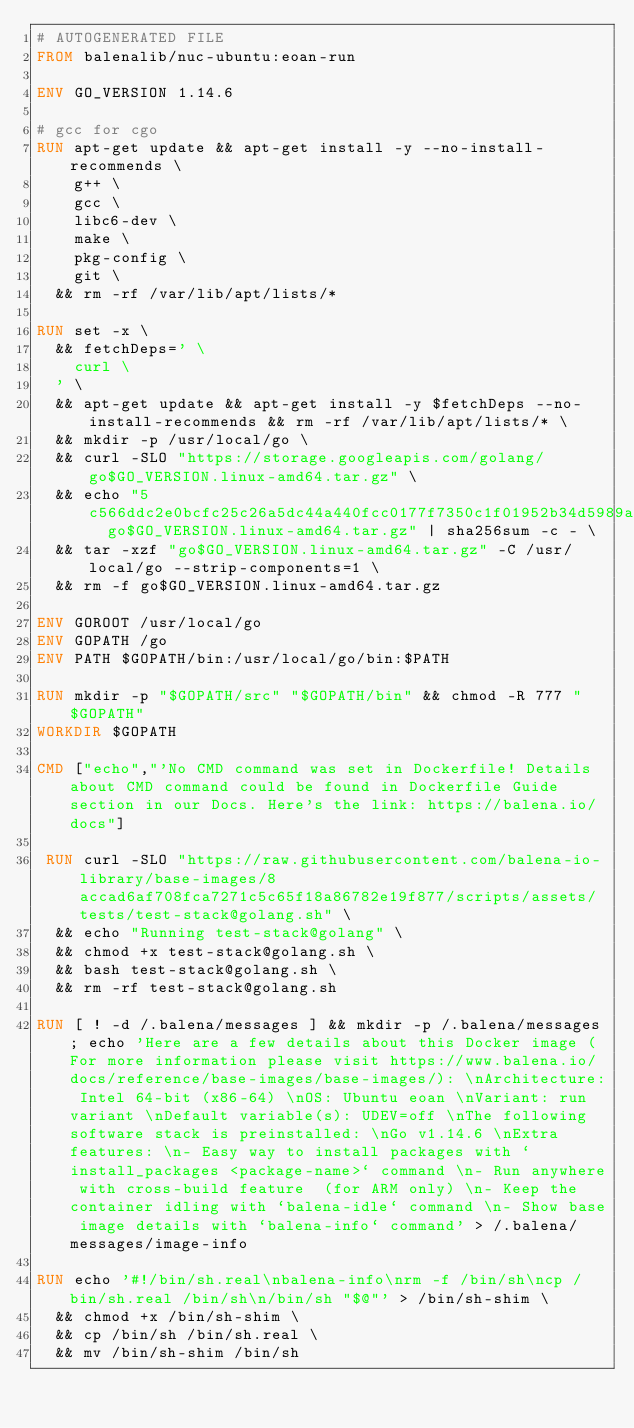Convert code to text. <code><loc_0><loc_0><loc_500><loc_500><_Dockerfile_># AUTOGENERATED FILE
FROM balenalib/nuc-ubuntu:eoan-run

ENV GO_VERSION 1.14.6

# gcc for cgo
RUN apt-get update && apt-get install -y --no-install-recommends \
		g++ \
		gcc \
		libc6-dev \
		make \
		pkg-config \
		git \
	&& rm -rf /var/lib/apt/lists/*

RUN set -x \
	&& fetchDeps=' \
		curl \
	' \
	&& apt-get update && apt-get install -y $fetchDeps --no-install-recommends && rm -rf /var/lib/apt/lists/* \
	&& mkdir -p /usr/local/go \
	&& curl -SLO "https://storage.googleapis.com/golang/go$GO_VERSION.linux-amd64.tar.gz" \
	&& echo "5c566ddc2e0bcfc25c26a5dc44a440fcc0177f7350c1f01952b34d5989a0d287  go$GO_VERSION.linux-amd64.tar.gz" | sha256sum -c - \
	&& tar -xzf "go$GO_VERSION.linux-amd64.tar.gz" -C /usr/local/go --strip-components=1 \
	&& rm -f go$GO_VERSION.linux-amd64.tar.gz

ENV GOROOT /usr/local/go
ENV GOPATH /go
ENV PATH $GOPATH/bin:/usr/local/go/bin:$PATH

RUN mkdir -p "$GOPATH/src" "$GOPATH/bin" && chmod -R 777 "$GOPATH"
WORKDIR $GOPATH

CMD ["echo","'No CMD command was set in Dockerfile! Details about CMD command could be found in Dockerfile Guide section in our Docs. Here's the link: https://balena.io/docs"]

 RUN curl -SLO "https://raw.githubusercontent.com/balena-io-library/base-images/8accad6af708fca7271c5c65f18a86782e19f877/scripts/assets/tests/test-stack@golang.sh" \
  && echo "Running test-stack@golang" \
  && chmod +x test-stack@golang.sh \
  && bash test-stack@golang.sh \
  && rm -rf test-stack@golang.sh 

RUN [ ! -d /.balena/messages ] && mkdir -p /.balena/messages; echo 'Here are a few details about this Docker image (For more information please visit https://www.balena.io/docs/reference/base-images/base-images/): \nArchitecture: Intel 64-bit (x86-64) \nOS: Ubuntu eoan \nVariant: run variant \nDefault variable(s): UDEV=off \nThe following software stack is preinstalled: \nGo v1.14.6 \nExtra features: \n- Easy way to install packages with `install_packages <package-name>` command \n- Run anywhere with cross-build feature  (for ARM only) \n- Keep the container idling with `balena-idle` command \n- Show base image details with `balena-info` command' > /.balena/messages/image-info

RUN echo '#!/bin/sh.real\nbalena-info\nrm -f /bin/sh\ncp /bin/sh.real /bin/sh\n/bin/sh "$@"' > /bin/sh-shim \
	&& chmod +x /bin/sh-shim \
	&& cp /bin/sh /bin/sh.real \
	&& mv /bin/sh-shim /bin/sh</code> 